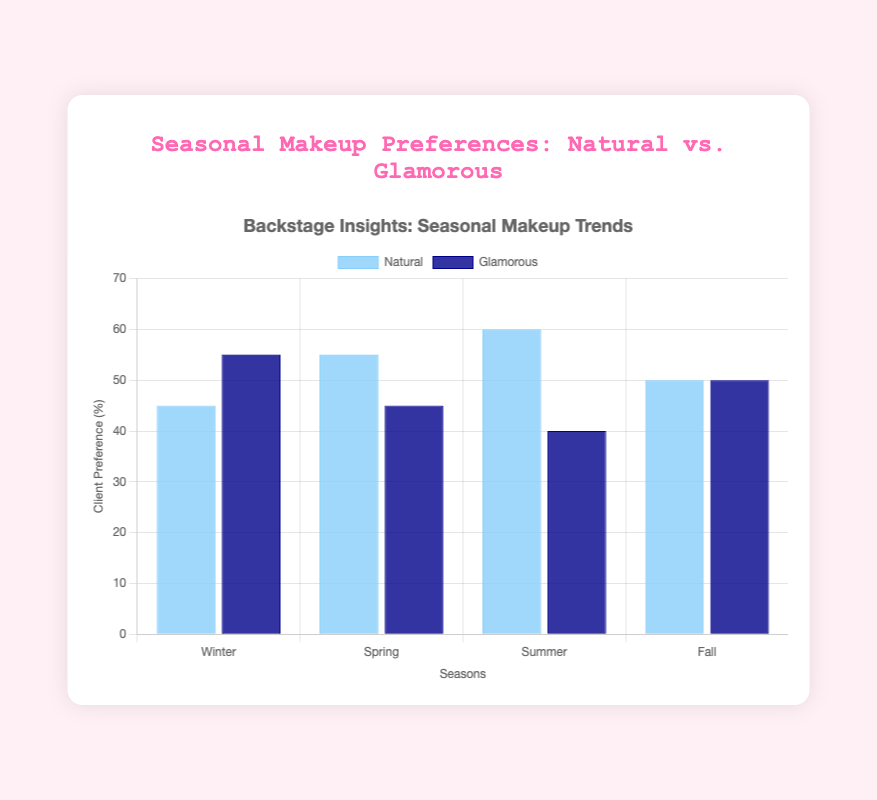What season has the highest preference for natural looks? By looking at the natural look bars, we see that Summer has the highest preference for natural looks with 60%.
Answer: Summer Which season sees equal preference for natural and glamorous looks? Both the natural and glamorous look bars for Fall are at 50%, indicating equal preference.
Answer: Fall By how many percentage points does the preference for natural looks in Winter differ from glamorous looks? For Winter, natural looks are preferred by 45% and glamorous by 55%, so the difference is 55% - 45% = 10 percentage points.
Answer: 10 percentage points What is the combined total percentage preference for natural looks in Spring and Fall? Add the preferences for natural looks in Spring (55%) and Fall (50%); 55% + 50% = 105%.
Answer: 105% Which season has the smallest difference in client preferences between natural and glamorous looks, and what is that difference? For each season, the differences are: Winter 10%, Spring 10%, Summer 20%, Fall 0%. The smallest difference is in Fall with 0%.
Answer: Fall, 0% Which season experiences the largest preference shift between natural and glamorous looks? Comparing the differences between natural and glamorous for each season: Winter (10%), Spring (10%), Summer (20%), and Fall (0%). The largest shift is in Summer with 20%.
Answer: Summer, 20% In which season do clients prefer glamorous looks over natural looks the most? In Winter, the glamorous looks have a higher count over natural by a margin of 10 percentage points (55% vs 45%).
Answer: Winter What is the average preference for natural looks across all seasons? Adding preferences for natural looks across all seasons: 45% + 55% + 60% + 50% = 210%. Dividing by 4 seasons gives 210% / 4 = 52.5%.
Answer: 52.5% How does the preference for natural looks in Summer compare to Spring? Summer has a 60% preference for natural looks while Spring has 55%, making Summer 5 percentage points higher.
Answer: 5 percentage points higher in Summer Which season shows the least variance between the preferences for natural and glamorous looks? In Fall, the preference is equally split between natural and glamorous looks at 50% each, showing no variance.
Answer: Fall 